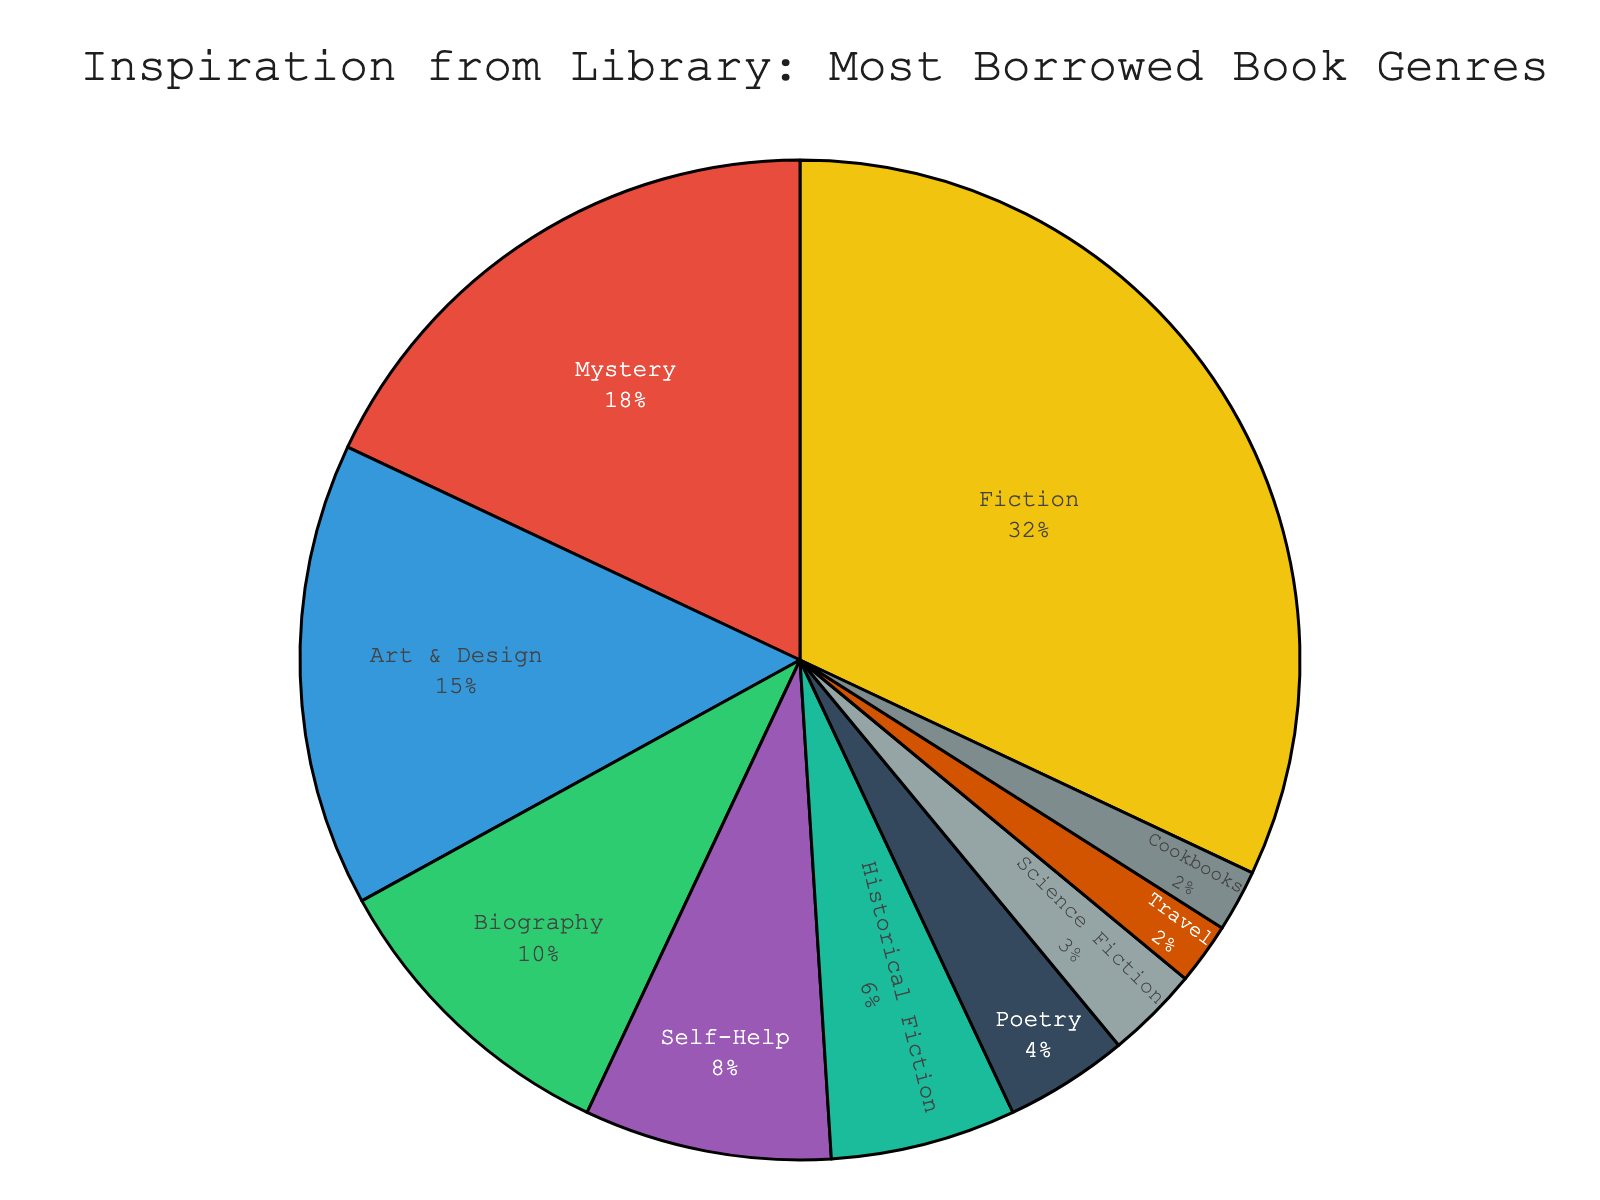What's the most borrowed genre in the community library? The pie chart shows the percentage breakdown of genres based on the most borrowed books. The largest section belongs to Fiction, indicating it is the most borrowed genre.
Answer: Fiction Which genre has the least percentage of borrowed books? By looking at the smallest segment on the pie chart, we can see that both Travel and Cookbooks each take up the least space, implying they have the smallest percentages.
Answer: Travel and Cookbooks What is the combined percentage of borrowed books for Fiction and Mystery genres? According to the pie chart, Fiction has 32% and Mystery has 18%. Adding these together gives us 32% + 18% = 50%.
Answer: 50% Are more people borrowing books from the Art & Design genre or the Self-Help genre? The chart indicates that Art & Design has a larger segment of 15%, while Self-Help has a smaller segment of 8%. Therefore, more people are borrowing Art & Design books.
Answer: Art & Design How does the percentage of borrowed Historical Fiction books compare to the percentage of borrowed Biography books? Historical Fiction has a percentage of 6% and Biography has 10%. Since 6% is less than 10%, Historical Fiction is borrowed less than Biography.
Answer: Historical Fiction is less than Biography What is the combined percentage of borrowed books from genres with less than 5% each? Adding the percentages from Poetry (4%), Science Fiction (3%), Travel (2%), and Cookbooks (2%) gives us 4% + 3% + 2% + 2% = 11%.
Answer: 11% Which genre occupies the green color segment in the pie chart? By referring to the chart and noting the color assigned to genres, the green segment corresponds to Art & Design.
Answer: Art & Design Which genres have a higher percentage of borrowed books than Poetry, but less than Biography? Poetry has 4%, and Biography has 10%. The genres that fall between 4% and 10% are Self-Help (8%) and Historical Fiction (6%).
Answer: Self-Help and Historical Fiction What percentage more is the Fiction genre borrowed compared to Science Fiction? Fiction is at 32% and Science Fiction at 3%. The difference is calculated as 32% - 3% = 29%.
Answer: 29% What is the difference in the percentage of borrowed books between Mystery and Art & Design genres? Mystery has 18% and Art & Design has 15%. The difference is 18% - 15% = 3%.
Answer: 3% 